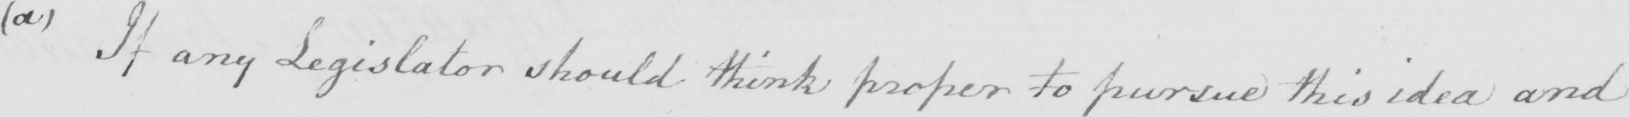What is written in this line of handwriting? ( a )  If any Legislator should think proper to pursue this idea and 